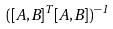Convert formula to latex. <formula><loc_0><loc_0><loc_500><loc_500>( [ A , B ] ^ { T } [ A , B ] ) ^ { - 1 }</formula> 